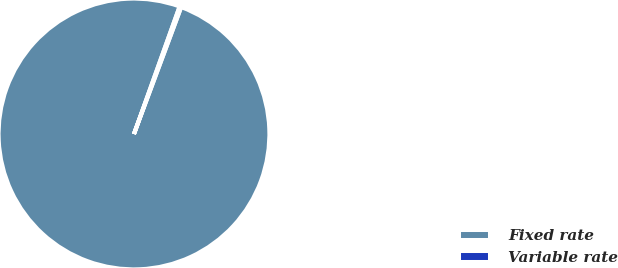<chart> <loc_0><loc_0><loc_500><loc_500><pie_chart><fcel>Fixed rate<fcel>Variable rate<nl><fcel>99.8%<fcel>0.2%<nl></chart> 